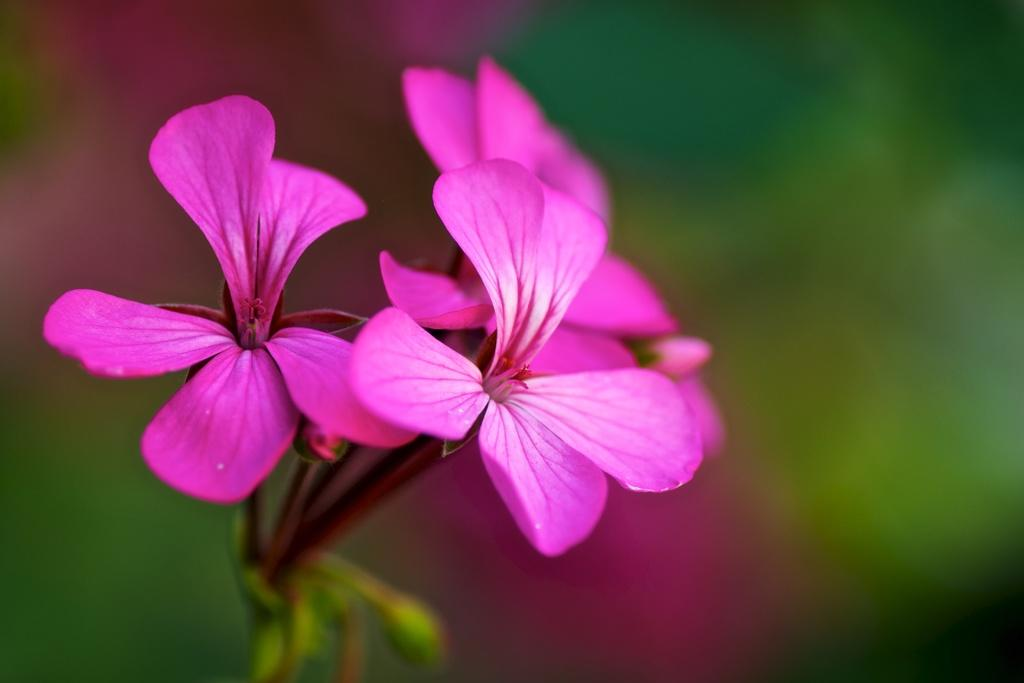What type of plant is visible in the image? There are flowers on a plant in the image. Can you describe the background of the image? The background of the image is blurry. What type of attack is being carried out by the flowers in the image? There is no attack being carried out by the flowers in the image; they are simply growing on the plant. What shape are the flowers in the image? The provided facts do not give enough information to determine the shape of the flowers in the image. 